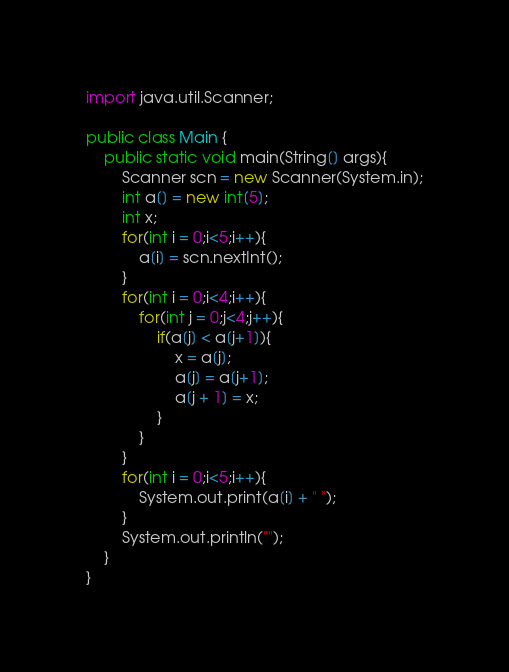Convert code to text. <code><loc_0><loc_0><loc_500><loc_500><_Java_>import java.util.Scanner;

public class Main {
	public static void main(String[] args){
		Scanner scn = new Scanner(System.in);
		int a[] = new int[5];
		int x;
		for(int i = 0;i<5;i++){
			a[i] = scn.nextInt();
		}
		for(int i = 0;i<4;i++){
			for(int j = 0;j<4;j++){
				if(a[j] < a[j+1]){
					x = a[j];
					a[j] = a[j+1];
					a[j + 1] = x;
				}
			}
		}
		for(int i = 0;i<5;i++){
			System.out.print(a[i] + " ");
		}
		System.out.println("");
	}
}</code> 